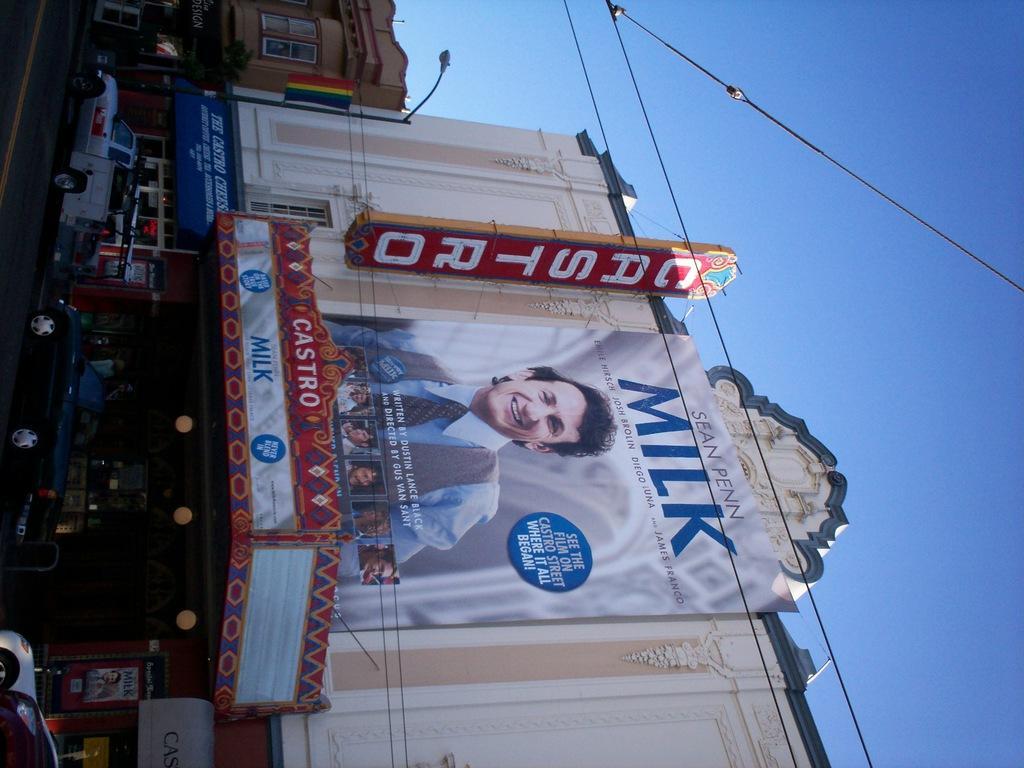Can you describe this image briefly? In the foreground of this image, there is a building, few posters and the lights. On the left, there are vehicles moving on the road. On the right, there is the sky and the cables. On the top, there is a building and street light. 